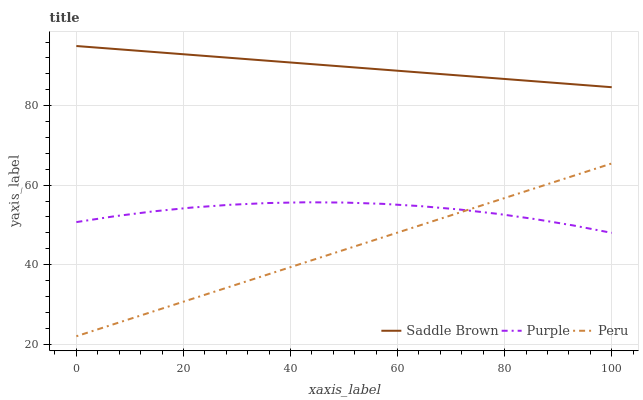Does Peru have the minimum area under the curve?
Answer yes or no. Yes. Does Saddle Brown have the maximum area under the curve?
Answer yes or no. Yes. Does Saddle Brown have the minimum area under the curve?
Answer yes or no. No. Does Peru have the maximum area under the curve?
Answer yes or no. No. Is Peru the smoothest?
Answer yes or no. Yes. Is Purple the roughest?
Answer yes or no. Yes. Is Saddle Brown the smoothest?
Answer yes or no. No. Is Saddle Brown the roughest?
Answer yes or no. No. Does Peru have the lowest value?
Answer yes or no. Yes. Does Saddle Brown have the lowest value?
Answer yes or no. No. Does Saddle Brown have the highest value?
Answer yes or no. Yes. Does Peru have the highest value?
Answer yes or no. No. Is Peru less than Saddle Brown?
Answer yes or no. Yes. Is Saddle Brown greater than Peru?
Answer yes or no. Yes. Does Peru intersect Purple?
Answer yes or no. Yes. Is Peru less than Purple?
Answer yes or no. No. Is Peru greater than Purple?
Answer yes or no. No. Does Peru intersect Saddle Brown?
Answer yes or no. No. 